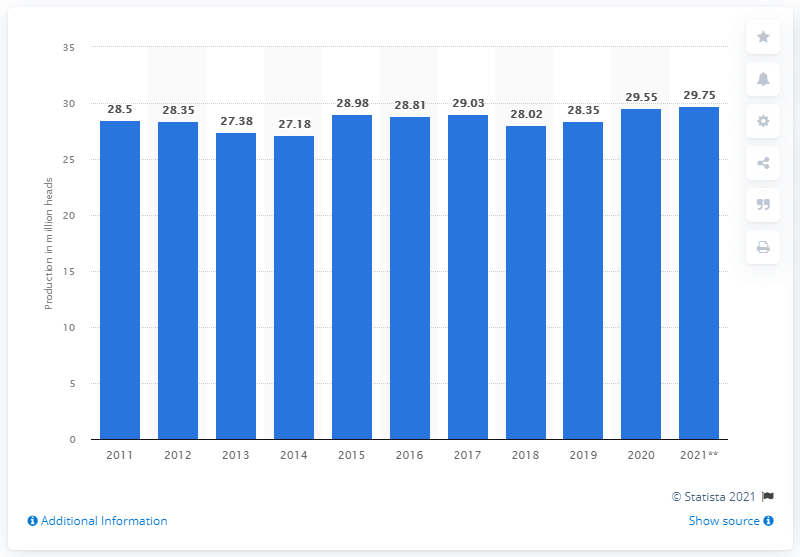Indicate a few pertinent items in this graphic. In 2020, the production of swine in Canada was 29.75 million. The production of swine in the previous year was 28.35. 